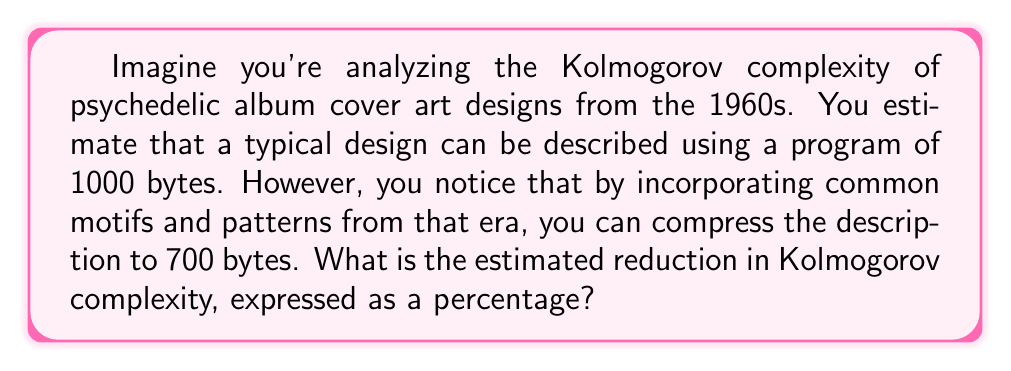Help me with this question. To solve this problem, we need to understand the concept of Kolmogorov complexity and how to calculate the percentage reduction. Let's break it down step-by-step:

1) Kolmogorov complexity is a measure of the computational resources needed to specify an object. In this case, it's represented by the number of bytes required to describe the album cover art.

2) Initial complexity: 1000 bytes
   Reduced complexity: 700 bytes

3) To calculate the reduction, we first find the difference:
   $$\text{Reduction} = 1000 - 700 = 300 \text{ bytes}$$

4) To express this as a percentage, we use the formula:
   $$\text{Percentage reduction} = \frac{\text{Reduction}}{\text{Initial complexity}} \times 100\%$$

5) Plugging in our values:
   $$\text{Percentage reduction} = \frac{300}{1000} \times 100\%$$

6) Simplifying:
   $$\text{Percentage reduction} = 0.3 \times 100\% = 30\%$$

Therefore, the estimated reduction in Kolmogorov complexity is 30%.
Answer: 30% 